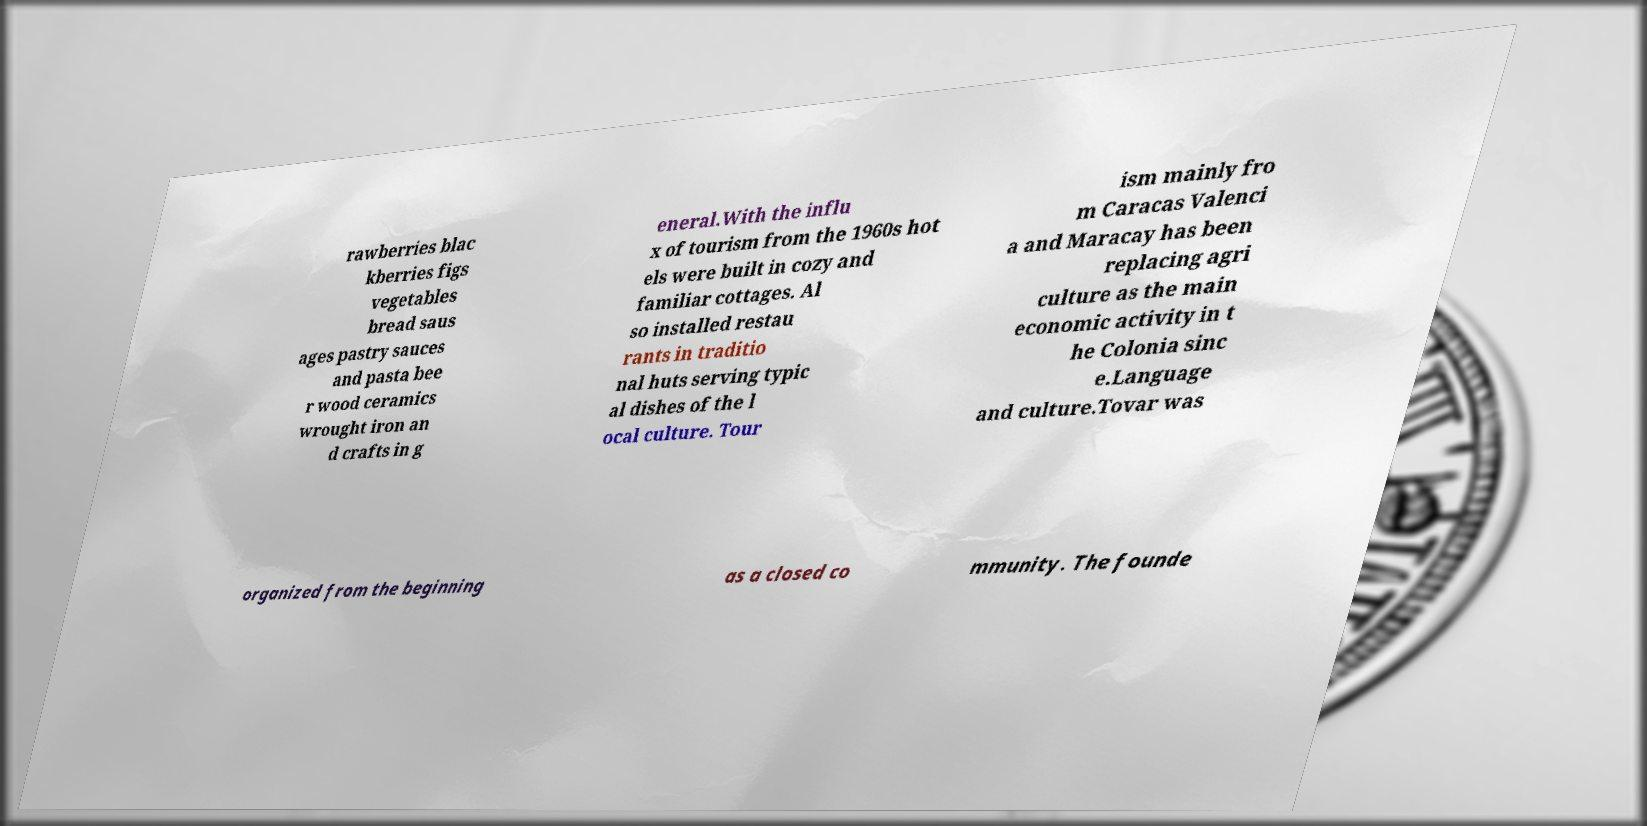For documentation purposes, I need the text within this image transcribed. Could you provide that? rawberries blac kberries figs vegetables bread saus ages pastry sauces and pasta bee r wood ceramics wrought iron an d crafts in g eneral.With the influ x of tourism from the 1960s hot els were built in cozy and familiar cottages. Al so installed restau rants in traditio nal huts serving typic al dishes of the l ocal culture. Tour ism mainly fro m Caracas Valenci a and Maracay has been replacing agri culture as the main economic activity in t he Colonia sinc e.Language and culture.Tovar was organized from the beginning as a closed co mmunity. The founde 